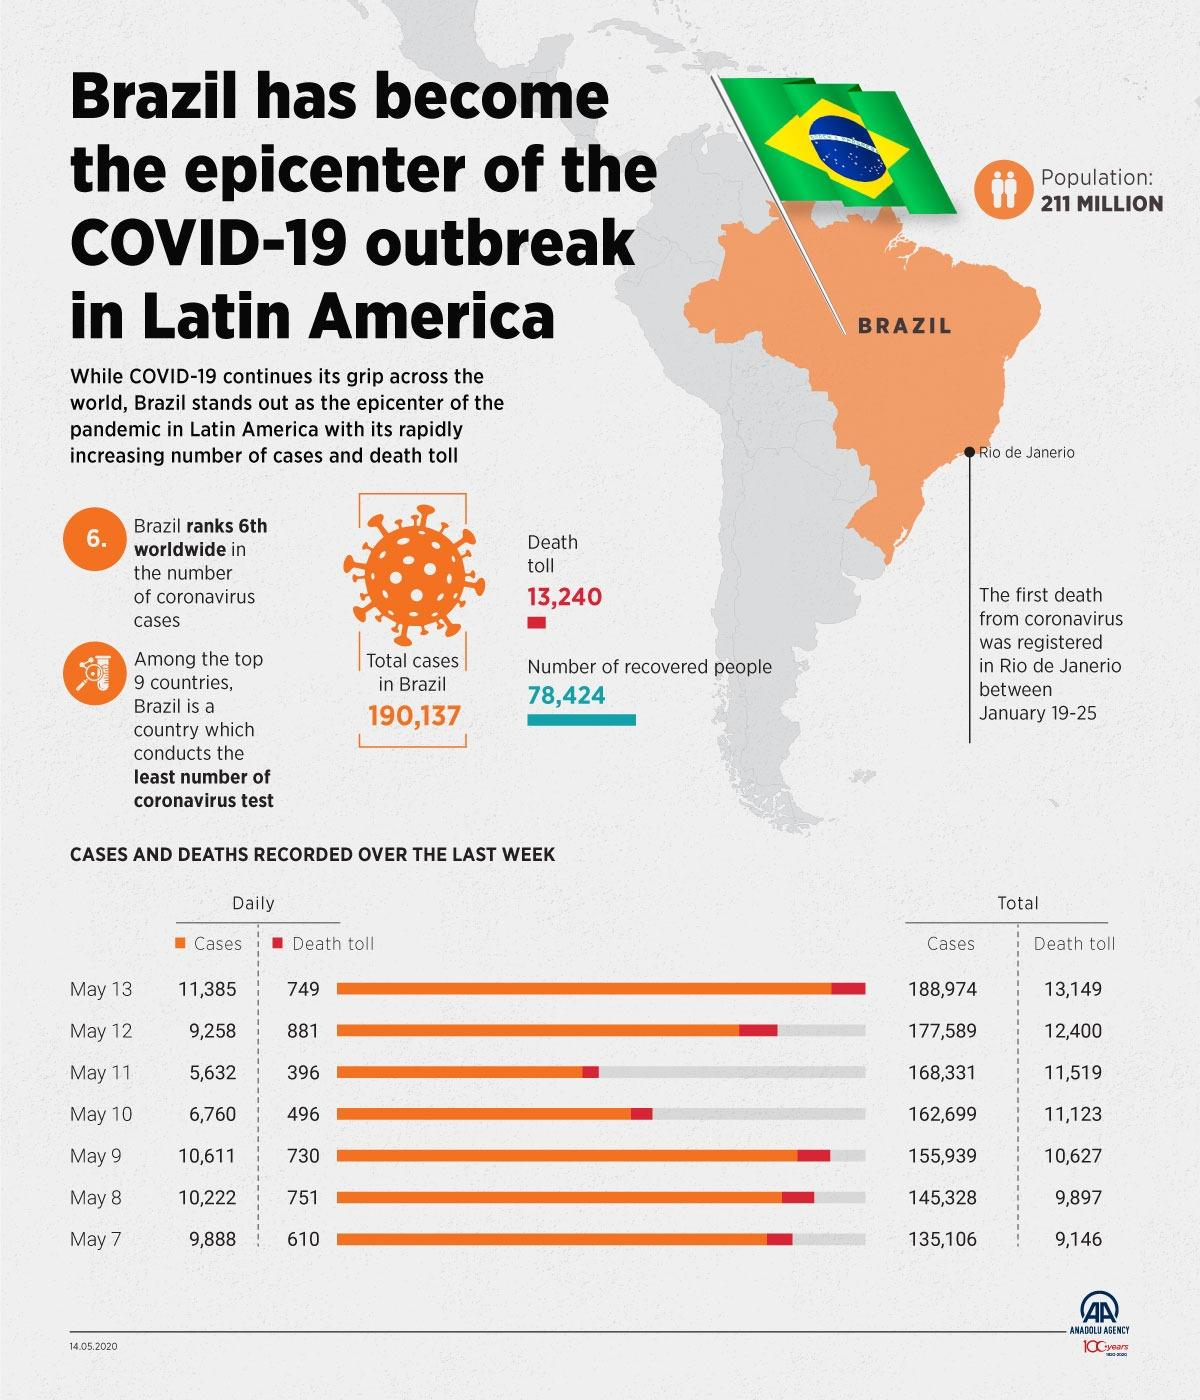Point out several critical features in this image. From May 7th to May 10th, there has been an increase in cases of 27,593. On the 10th and 11th of May, the total number of deaths was 892. On May 12 and 13, there were 1630 deaths. Brazil is ranked among the countries that conduct the least number of tests. The first reported death from the coronavirus in Brazil occurred in Rio de Janeiro. 